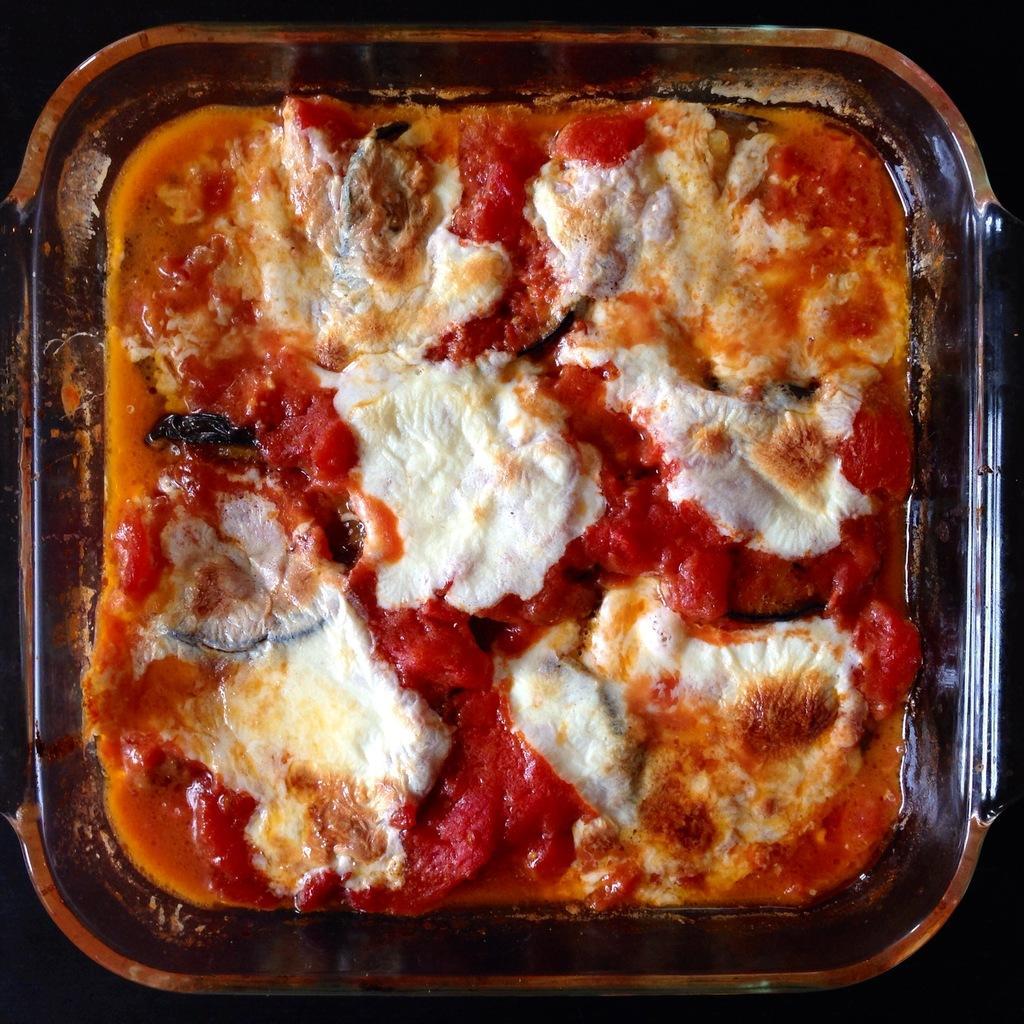Describe this image in one or two sentences. In this image I can see a plastic plate and in it I can see food. I can see colour of this food is white and red. 